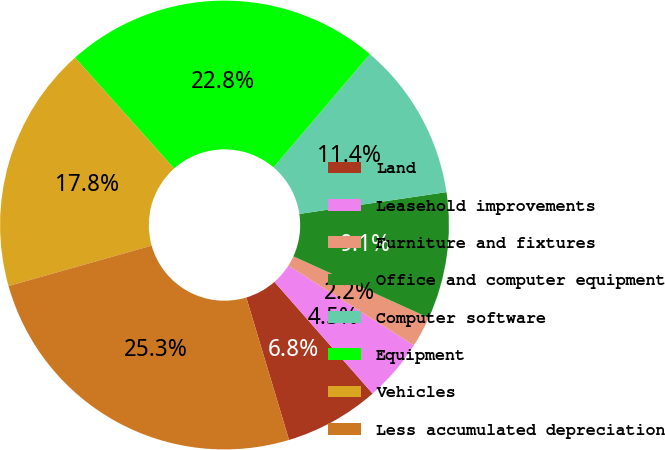Convert chart. <chart><loc_0><loc_0><loc_500><loc_500><pie_chart><fcel>Land<fcel>Leasehold improvements<fcel>Furniture and fixtures<fcel>Office and computer equipment<fcel>Computer software<fcel>Equipment<fcel>Vehicles<fcel>Less accumulated depreciation<nl><fcel>6.83%<fcel>4.52%<fcel>2.22%<fcel>9.13%<fcel>11.43%<fcel>22.83%<fcel>17.78%<fcel>25.26%<nl></chart> 